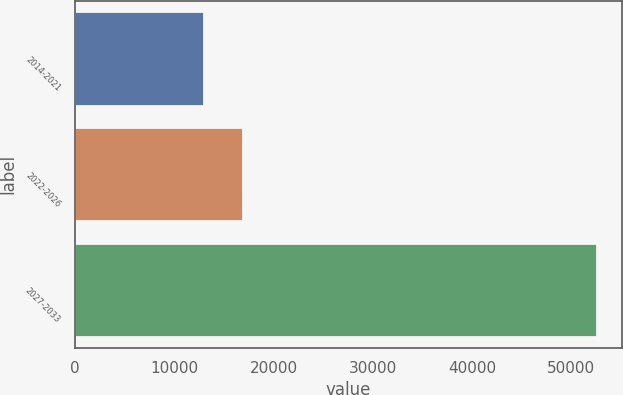<chart> <loc_0><loc_0><loc_500><loc_500><bar_chart><fcel>2014-2021<fcel>2022-2026<fcel>2027-2033<nl><fcel>12916<fcel>16872.2<fcel>52478<nl></chart> 